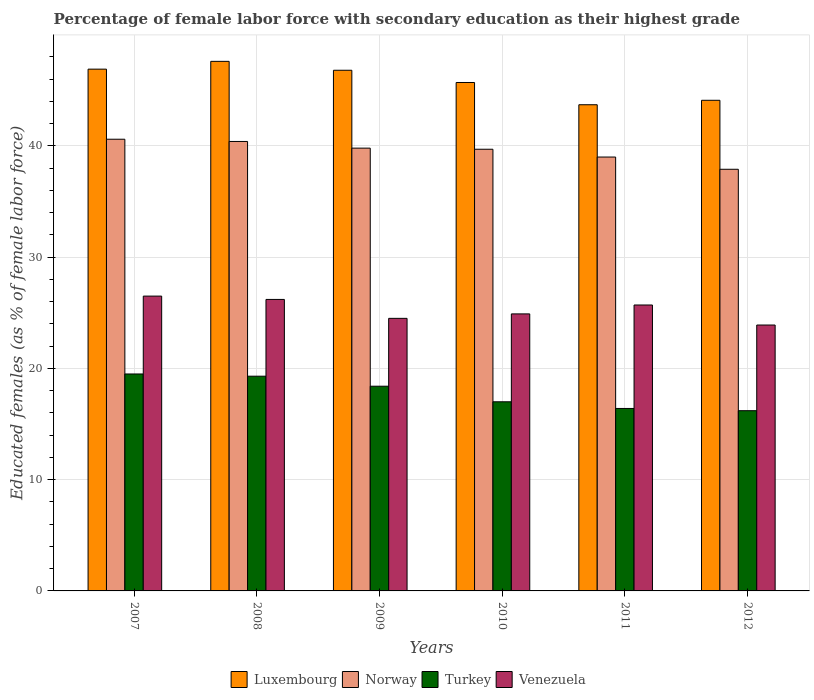How many different coloured bars are there?
Provide a short and direct response. 4. Are the number of bars on each tick of the X-axis equal?
Make the answer very short. Yes. How many bars are there on the 6th tick from the right?
Provide a short and direct response. 4. In how many cases, is the number of bars for a given year not equal to the number of legend labels?
Your answer should be compact. 0. What is the percentage of female labor force with secondary education in Norway in 2008?
Your answer should be very brief. 40.4. Across all years, what is the maximum percentage of female labor force with secondary education in Venezuela?
Your answer should be very brief. 26.5. Across all years, what is the minimum percentage of female labor force with secondary education in Turkey?
Your answer should be very brief. 16.2. In which year was the percentage of female labor force with secondary education in Norway maximum?
Give a very brief answer. 2007. What is the total percentage of female labor force with secondary education in Luxembourg in the graph?
Your answer should be compact. 274.8. What is the difference between the percentage of female labor force with secondary education in Turkey in 2010 and that in 2011?
Make the answer very short. 0.6. What is the difference between the percentage of female labor force with secondary education in Turkey in 2007 and the percentage of female labor force with secondary education in Norway in 2009?
Give a very brief answer. -20.3. What is the average percentage of female labor force with secondary education in Luxembourg per year?
Give a very brief answer. 45.8. In the year 2009, what is the difference between the percentage of female labor force with secondary education in Luxembourg and percentage of female labor force with secondary education in Norway?
Make the answer very short. 7. What is the ratio of the percentage of female labor force with secondary education in Luxembourg in 2009 to that in 2011?
Keep it short and to the point. 1.07. Is the percentage of female labor force with secondary education in Turkey in 2007 less than that in 2011?
Your response must be concise. No. What is the difference between the highest and the second highest percentage of female labor force with secondary education in Turkey?
Make the answer very short. 0.2. What is the difference between the highest and the lowest percentage of female labor force with secondary education in Venezuela?
Your answer should be very brief. 2.6. In how many years, is the percentage of female labor force with secondary education in Norway greater than the average percentage of female labor force with secondary education in Norway taken over all years?
Offer a terse response. 4. Is the sum of the percentage of female labor force with secondary education in Venezuela in 2008 and 2011 greater than the maximum percentage of female labor force with secondary education in Turkey across all years?
Your response must be concise. Yes. Is it the case that in every year, the sum of the percentage of female labor force with secondary education in Luxembourg and percentage of female labor force with secondary education in Norway is greater than the sum of percentage of female labor force with secondary education in Turkey and percentage of female labor force with secondary education in Venezuela?
Offer a terse response. Yes. What does the 1st bar from the left in 2007 represents?
Give a very brief answer. Luxembourg. Is it the case that in every year, the sum of the percentage of female labor force with secondary education in Luxembourg and percentage of female labor force with secondary education in Norway is greater than the percentage of female labor force with secondary education in Venezuela?
Provide a short and direct response. Yes. How many bars are there?
Your answer should be very brief. 24. Are all the bars in the graph horizontal?
Provide a short and direct response. No. What is the difference between two consecutive major ticks on the Y-axis?
Ensure brevity in your answer.  10. Does the graph contain any zero values?
Your answer should be very brief. No. Does the graph contain grids?
Keep it short and to the point. Yes. Where does the legend appear in the graph?
Your answer should be compact. Bottom center. What is the title of the graph?
Provide a short and direct response. Percentage of female labor force with secondary education as their highest grade. Does "Montenegro" appear as one of the legend labels in the graph?
Ensure brevity in your answer.  No. What is the label or title of the X-axis?
Provide a succinct answer. Years. What is the label or title of the Y-axis?
Your answer should be compact. Educated females (as % of female labor force). What is the Educated females (as % of female labor force) of Luxembourg in 2007?
Offer a terse response. 46.9. What is the Educated females (as % of female labor force) in Norway in 2007?
Make the answer very short. 40.6. What is the Educated females (as % of female labor force) in Turkey in 2007?
Ensure brevity in your answer.  19.5. What is the Educated females (as % of female labor force) in Luxembourg in 2008?
Keep it short and to the point. 47.6. What is the Educated females (as % of female labor force) of Norway in 2008?
Give a very brief answer. 40.4. What is the Educated females (as % of female labor force) of Turkey in 2008?
Keep it short and to the point. 19.3. What is the Educated females (as % of female labor force) of Venezuela in 2008?
Offer a very short reply. 26.2. What is the Educated females (as % of female labor force) of Luxembourg in 2009?
Make the answer very short. 46.8. What is the Educated females (as % of female labor force) of Norway in 2009?
Your response must be concise. 39.8. What is the Educated females (as % of female labor force) in Turkey in 2009?
Give a very brief answer. 18.4. What is the Educated females (as % of female labor force) in Venezuela in 2009?
Provide a short and direct response. 24.5. What is the Educated females (as % of female labor force) in Luxembourg in 2010?
Offer a very short reply. 45.7. What is the Educated females (as % of female labor force) in Norway in 2010?
Your response must be concise. 39.7. What is the Educated females (as % of female labor force) in Venezuela in 2010?
Your response must be concise. 24.9. What is the Educated females (as % of female labor force) in Luxembourg in 2011?
Your answer should be very brief. 43.7. What is the Educated females (as % of female labor force) of Turkey in 2011?
Your answer should be compact. 16.4. What is the Educated females (as % of female labor force) in Venezuela in 2011?
Provide a succinct answer. 25.7. What is the Educated females (as % of female labor force) in Luxembourg in 2012?
Provide a succinct answer. 44.1. What is the Educated females (as % of female labor force) of Norway in 2012?
Offer a very short reply. 37.9. What is the Educated females (as % of female labor force) of Turkey in 2012?
Your answer should be compact. 16.2. What is the Educated females (as % of female labor force) in Venezuela in 2012?
Give a very brief answer. 23.9. Across all years, what is the maximum Educated females (as % of female labor force) of Luxembourg?
Ensure brevity in your answer.  47.6. Across all years, what is the maximum Educated females (as % of female labor force) in Norway?
Ensure brevity in your answer.  40.6. Across all years, what is the maximum Educated females (as % of female labor force) in Turkey?
Your answer should be very brief. 19.5. Across all years, what is the maximum Educated females (as % of female labor force) in Venezuela?
Provide a short and direct response. 26.5. Across all years, what is the minimum Educated females (as % of female labor force) in Luxembourg?
Your answer should be very brief. 43.7. Across all years, what is the minimum Educated females (as % of female labor force) in Norway?
Make the answer very short. 37.9. Across all years, what is the minimum Educated females (as % of female labor force) in Turkey?
Offer a terse response. 16.2. Across all years, what is the minimum Educated females (as % of female labor force) of Venezuela?
Give a very brief answer. 23.9. What is the total Educated females (as % of female labor force) of Luxembourg in the graph?
Your answer should be compact. 274.8. What is the total Educated females (as % of female labor force) of Norway in the graph?
Give a very brief answer. 237.4. What is the total Educated females (as % of female labor force) in Turkey in the graph?
Provide a succinct answer. 106.8. What is the total Educated females (as % of female labor force) in Venezuela in the graph?
Provide a succinct answer. 151.7. What is the difference between the Educated females (as % of female labor force) in Luxembourg in 2007 and that in 2008?
Offer a very short reply. -0.7. What is the difference between the Educated females (as % of female labor force) in Norway in 2007 and that in 2008?
Offer a terse response. 0.2. What is the difference between the Educated females (as % of female labor force) in Turkey in 2007 and that in 2008?
Your answer should be compact. 0.2. What is the difference between the Educated females (as % of female labor force) of Luxembourg in 2007 and that in 2009?
Your response must be concise. 0.1. What is the difference between the Educated females (as % of female labor force) in Norway in 2007 and that in 2009?
Your answer should be compact. 0.8. What is the difference between the Educated females (as % of female labor force) of Luxembourg in 2007 and that in 2011?
Make the answer very short. 3.2. What is the difference between the Educated females (as % of female labor force) of Turkey in 2007 and that in 2011?
Provide a short and direct response. 3.1. What is the difference between the Educated females (as % of female labor force) of Venezuela in 2007 and that in 2011?
Your answer should be compact. 0.8. What is the difference between the Educated females (as % of female labor force) of Luxembourg in 2007 and that in 2012?
Give a very brief answer. 2.8. What is the difference between the Educated females (as % of female labor force) in Luxembourg in 2008 and that in 2009?
Make the answer very short. 0.8. What is the difference between the Educated females (as % of female labor force) in Turkey in 2008 and that in 2009?
Keep it short and to the point. 0.9. What is the difference between the Educated females (as % of female labor force) in Venezuela in 2008 and that in 2009?
Your answer should be very brief. 1.7. What is the difference between the Educated females (as % of female labor force) in Norway in 2008 and that in 2010?
Offer a terse response. 0.7. What is the difference between the Educated females (as % of female labor force) of Venezuela in 2008 and that in 2010?
Offer a terse response. 1.3. What is the difference between the Educated females (as % of female labor force) in Luxembourg in 2008 and that in 2011?
Offer a very short reply. 3.9. What is the difference between the Educated females (as % of female labor force) in Venezuela in 2008 and that in 2011?
Offer a terse response. 0.5. What is the difference between the Educated females (as % of female labor force) of Turkey in 2008 and that in 2012?
Offer a very short reply. 3.1. What is the difference between the Educated females (as % of female labor force) of Luxembourg in 2009 and that in 2010?
Provide a short and direct response. 1.1. What is the difference between the Educated females (as % of female labor force) of Norway in 2009 and that in 2011?
Keep it short and to the point. 0.8. What is the difference between the Educated females (as % of female labor force) in Turkey in 2009 and that in 2011?
Ensure brevity in your answer.  2. What is the difference between the Educated females (as % of female labor force) of Venezuela in 2009 and that in 2011?
Offer a terse response. -1.2. What is the difference between the Educated females (as % of female labor force) in Luxembourg in 2009 and that in 2012?
Your response must be concise. 2.7. What is the difference between the Educated females (as % of female labor force) of Norway in 2009 and that in 2012?
Keep it short and to the point. 1.9. What is the difference between the Educated females (as % of female labor force) in Venezuela in 2009 and that in 2012?
Offer a very short reply. 0.6. What is the difference between the Educated females (as % of female labor force) of Norway in 2010 and that in 2011?
Keep it short and to the point. 0.7. What is the difference between the Educated females (as % of female labor force) in Turkey in 2010 and that in 2011?
Keep it short and to the point. 0.6. What is the difference between the Educated females (as % of female labor force) of Venezuela in 2010 and that in 2011?
Offer a very short reply. -0.8. What is the difference between the Educated females (as % of female labor force) of Luxembourg in 2010 and that in 2012?
Ensure brevity in your answer.  1.6. What is the difference between the Educated females (as % of female labor force) of Venezuela in 2011 and that in 2012?
Provide a short and direct response. 1.8. What is the difference between the Educated females (as % of female labor force) of Luxembourg in 2007 and the Educated females (as % of female labor force) of Turkey in 2008?
Your response must be concise. 27.6. What is the difference between the Educated females (as % of female labor force) of Luxembourg in 2007 and the Educated females (as % of female labor force) of Venezuela in 2008?
Provide a succinct answer. 20.7. What is the difference between the Educated females (as % of female labor force) in Norway in 2007 and the Educated females (as % of female labor force) in Turkey in 2008?
Ensure brevity in your answer.  21.3. What is the difference between the Educated females (as % of female labor force) in Turkey in 2007 and the Educated females (as % of female labor force) in Venezuela in 2008?
Give a very brief answer. -6.7. What is the difference between the Educated females (as % of female labor force) of Luxembourg in 2007 and the Educated females (as % of female labor force) of Turkey in 2009?
Offer a terse response. 28.5. What is the difference between the Educated females (as % of female labor force) of Luxembourg in 2007 and the Educated females (as % of female labor force) of Venezuela in 2009?
Keep it short and to the point. 22.4. What is the difference between the Educated females (as % of female labor force) of Norway in 2007 and the Educated females (as % of female labor force) of Turkey in 2009?
Offer a very short reply. 22.2. What is the difference between the Educated females (as % of female labor force) in Luxembourg in 2007 and the Educated females (as % of female labor force) in Turkey in 2010?
Give a very brief answer. 29.9. What is the difference between the Educated females (as % of female labor force) of Norway in 2007 and the Educated females (as % of female labor force) of Turkey in 2010?
Your response must be concise. 23.6. What is the difference between the Educated females (as % of female labor force) of Luxembourg in 2007 and the Educated females (as % of female labor force) of Turkey in 2011?
Offer a terse response. 30.5. What is the difference between the Educated females (as % of female labor force) in Luxembourg in 2007 and the Educated females (as % of female labor force) in Venezuela in 2011?
Your answer should be very brief. 21.2. What is the difference between the Educated females (as % of female labor force) of Norway in 2007 and the Educated females (as % of female labor force) of Turkey in 2011?
Make the answer very short. 24.2. What is the difference between the Educated females (as % of female labor force) of Norway in 2007 and the Educated females (as % of female labor force) of Venezuela in 2011?
Offer a very short reply. 14.9. What is the difference between the Educated females (as % of female labor force) in Turkey in 2007 and the Educated females (as % of female labor force) in Venezuela in 2011?
Ensure brevity in your answer.  -6.2. What is the difference between the Educated females (as % of female labor force) in Luxembourg in 2007 and the Educated females (as % of female labor force) in Turkey in 2012?
Provide a short and direct response. 30.7. What is the difference between the Educated females (as % of female labor force) of Luxembourg in 2007 and the Educated females (as % of female labor force) of Venezuela in 2012?
Your response must be concise. 23. What is the difference between the Educated females (as % of female labor force) in Norway in 2007 and the Educated females (as % of female labor force) in Turkey in 2012?
Provide a short and direct response. 24.4. What is the difference between the Educated females (as % of female labor force) of Turkey in 2007 and the Educated females (as % of female labor force) of Venezuela in 2012?
Make the answer very short. -4.4. What is the difference between the Educated females (as % of female labor force) in Luxembourg in 2008 and the Educated females (as % of female labor force) in Norway in 2009?
Ensure brevity in your answer.  7.8. What is the difference between the Educated females (as % of female labor force) of Luxembourg in 2008 and the Educated females (as % of female labor force) of Turkey in 2009?
Provide a short and direct response. 29.2. What is the difference between the Educated females (as % of female labor force) in Luxembourg in 2008 and the Educated females (as % of female labor force) in Venezuela in 2009?
Your answer should be compact. 23.1. What is the difference between the Educated females (as % of female labor force) of Norway in 2008 and the Educated females (as % of female labor force) of Venezuela in 2009?
Provide a short and direct response. 15.9. What is the difference between the Educated females (as % of female labor force) in Luxembourg in 2008 and the Educated females (as % of female labor force) in Norway in 2010?
Provide a short and direct response. 7.9. What is the difference between the Educated females (as % of female labor force) in Luxembourg in 2008 and the Educated females (as % of female labor force) in Turkey in 2010?
Ensure brevity in your answer.  30.6. What is the difference between the Educated females (as % of female labor force) of Luxembourg in 2008 and the Educated females (as % of female labor force) of Venezuela in 2010?
Provide a succinct answer. 22.7. What is the difference between the Educated females (as % of female labor force) of Norway in 2008 and the Educated females (as % of female labor force) of Turkey in 2010?
Offer a very short reply. 23.4. What is the difference between the Educated females (as % of female labor force) of Luxembourg in 2008 and the Educated females (as % of female labor force) of Turkey in 2011?
Ensure brevity in your answer.  31.2. What is the difference between the Educated females (as % of female labor force) of Luxembourg in 2008 and the Educated females (as % of female labor force) of Venezuela in 2011?
Offer a very short reply. 21.9. What is the difference between the Educated females (as % of female labor force) in Norway in 2008 and the Educated females (as % of female labor force) in Turkey in 2011?
Your answer should be compact. 24. What is the difference between the Educated females (as % of female labor force) of Luxembourg in 2008 and the Educated females (as % of female labor force) of Norway in 2012?
Keep it short and to the point. 9.7. What is the difference between the Educated females (as % of female labor force) in Luxembourg in 2008 and the Educated females (as % of female labor force) in Turkey in 2012?
Provide a succinct answer. 31.4. What is the difference between the Educated females (as % of female labor force) in Luxembourg in 2008 and the Educated females (as % of female labor force) in Venezuela in 2012?
Provide a succinct answer. 23.7. What is the difference between the Educated females (as % of female labor force) of Norway in 2008 and the Educated females (as % of female labor force) of Turkey in 2012?
Your answer should be compact. 24.2. What is the difference between the Educated females (as % of female labor force) of Turkey in 2008 and the Educated females (as % of female labor force) of Venezuela in 2012?
Your answer should be compact. -4.6. What is the difference between the Educated females (as % of female labor force) of Luxembourg in 2009 and the Educated females (as % of female labor force) of Turkey in 2010?
Offer a very short reply. 29.8. What is the difference between the Educated females (as % of female labor force) of Luxembourg in 2009 and the Educated females (as % of female labor force) of Venezuela in 2010?
Your response must be concise. 21.9. What is the difference between the Educated females (as % of female labor force) in Norway in 2009 and the Educated females (as % of female labor force) in Turkey in 2010?
Give a very brief answer. 22.8. What is the difference between the Educated females (as % of female labor force) in Luxembourg in 2009 and the Educated females (as % of female labor force) in Norway in 2011?
Give a very brief answer. 7.8. What is the difference between the Educated females (as % of female labor force) in Luxembourg in 2009 and the Educated females (as % of female labor force) in Turkey in 2011?
Make the answer very short. 30.4. What is the difference between the Educated females (as % of female labor force) of Luxembourg in 2009 and the Educated females (as % of female labor force) of Venezuela in 2011?
Your answer should be compact. 21.1. What is the difference between the Educated females (as % of female labor force) of Norway in 2009 and the Educated females (as % of female labor force) of Turkey in 2011?
Make the answer very short. 23.4. What is the difference between the Educated females (as % of female labor force) in Norway in 2009 and the Educated females (as % of female labor force) in Venezuela in 2011?
Your answer should be compact. 14.1. What is the difference between the Educated females (as % of female labor force) of Turkey in 2009 and the Educated females (as % of female labor force) of Venezuela in 2011?
Make the answer very short. -7.3. What is the difference between the Educated females (as % of female labor force) of Luxembourg in 2009 and the Educated females (as % of female labor force) of Turkey in 2012?
Make the answer very short. 30.6. What is the difference between the Educated females (as % of female labor force) in Luxembourg in 2009 and the Educated females (as % of female labor force) in Venezuela in 2012?
Your answer should be very brief. 22.9. What is the difference between the Educated females (as % of female labor force) in Norway in 2009 and the Educated females (as % of female labor force) in Turkey in 2012?
Make the answer very short. 23.6. What is the difference between the Educated females (as % of female labor force) in Turkey in 2009 and the Educated females (as % of female labor force) in Venezuela in 2012?
Your answer should be very brief. -5.5. What is the difference between the Educated females (as % of female labor force) in Luxembourg in 2010 and the Educated females (as % of female labor force) in Norway in 2011?
Ensure brevity in your answer.  6.7. What is the difference between the Educated females (as % of female labor force) in Luxembourg in 2010 and the Educated females (as % of female labor force) in Turkey in 2011?
Your response must be concise. 29.3. What is the difference between the Educated females (as % of female labor force) in Luxembourg in 2010 and the Educated females (as % of female labor force) in Venezuela in 2011?
Ensure brevity in your answer.  20. What is the difference between the Educated females (as % of female labor force) of Norway in 2010 and the Educated females (as % of female labor force) of Turkey in 2011?
Your answer should be compact. 23.3. What is the difference between the Educated females (as % of female labor force) in Norway in 2010 and the Educated females (as % of female labor force) in Venezuela in 2011?
Your answer should be compact. 14. What is the difference between the Educated females (as % of female labor force) in Luxembourg in 2010 and the Educated females (as % of female labor force) in Norway in 2012?
Offer a terse response. 7.8. What is the difference between the Educated females (as % of female labor force) in Luxembourg in 2010 and the Educated females (as % of female labor force) in Turkey in 2012?
Keep it short and to the point. 29.5. What is the difference between the Educated females (as % of female labor force) of Luxembourg in 2010 and the Educated females (as % of female labor force) of Venezuela in 2012?
Make the answer very short. 21.8. What is the difference between the Educated females (as % of female labor force) of Luxembourg in 2011 and the Educated females (as % of female labor force) of Norway in 2012?
Your answer should be compact. 5.8. What is the difference between the Educated females (as % of female labor force) in Luxembourg in 2011 and the Educated females (as % of female labor force) in Turkey in 2012?
Keep it short and to the point. 27.5. What is the difference between the Educated females (as % of female labor force) in Luxembourg in 2011 and the Educated females (as % of female labor force) in Venezuela in 2012?
Offer a very short reply. 19.8. What is the difference between the Educated females (as % of female labor force) in Norway in 2011 and the Educated females (as % of female labor force) in Turkey in 2012?
Give a very brief answer. 22.8. What is the difference between the Educated females (as % of female labor force) in Norway in 2011 and the Educated females (as % of female labor force) in Venezuela in 2012?
Provide a succinct answer. 15.1. What is the average Educated females (as % of female labor force) in Luxembourg per year?
Provide a succinct answer. 45.8. What is the average Educated females (as % of female labor force) of Norway per year?
Make the answer very short. 39.57. What is the average Educated females (as % of female labor force) in Turkey per year?
Keep it short and to the point. 17.8. What is the average Educated females (as % of female labor force) in Venezuela per year?
Your answer should be compact. 25.28. In the year 2007, what is the difference between the Educated females (as % of female labor force) in Luxembourg and Educated females (as % of female labor force) in Turkey?
Give a very brief answer. 27.4. In the year 2007, what is the difference between the Educated females (as % of female labor force) of Luxembourg and Educated females (as % of female labor force) of Venezuela?
Make the answer very short. 20.4. In the year 2007, what is the difference between the Educated females (as % of female labor force) in Norway and Educated females (as % of female labor force) in Turkey?
Provide a short and direct response. 21.1. In the year 2007, what is the difference between the Educated females (as % of female labor force) of Norway and Educated females (as % of female labor force) of Venezuela?
Offer a very short reply. 14.1. In the year 2007, what is the difference between the Educated females (as % of female labor force) of Turkey and Educated females (as % of female labor force) of Venezuela?
Give a very brief answer. -7. In the year 2008, what is the difference between the Educated females (as % of female labor force) of Luxembourg and Educated females (as % of female labor force) of Norway?
Offer a very short reply. 7.2. In the year 2008, what is the difference between the Educated females (as % of female labor force) of Luxembourg and Educated females (as % of female labor force) of Turkey?
Offer a very short reply. 28.3. In the year 2008, what is the difference between the Educated females (as % of female labor force) of Luxembourg and Educated females (as % of female labor force) of Venezuela?
Your answer should be very brief. 21.4. In the year 2008, what is the difference between the Educated females (as % of female labor force) of Norway and Educated females (as % of female labor force) of Turkey?
Make the answer very short. 21.1. In the year 2009, what is the difference between the Educated females (as % of female labor force) in Luxembourg and Educated females (as % of female labor force) in Turkey?
Provide a short and direct response. 28.4. In the year 2009, what is the difference between the Educated females (as % of female labor force) in Luxembourg and Educated females (as % of female labor force) in Venezuela?
Offer a terse response. 22.3. In the year 2009, what is the difference between the Educated females (as % of female labor force) in Norway and Educated females (as % of female labor force) in Turkey?
Offer a very short reply. 21.4. In the year 2010, what is the difference between the Educated females (as % of female labor force) in Luxembourg and Educated females (as % of female labor force) in Norway?
Give a very brief answer. 6. In the year 2010, what is the difference between the Educated females (as % of female labor force) in Luxembourg and Educated females (as % of female labor force) in Turkey?
Ensure brevity in your answer.  28.7. In the year 2010, what is the difference between the Educated females (as % of female labor force) in Luxembourg and Educated females (as % of female labor force) in Venezuela?
Your response must be concise. 20.8. In the year 2010, what is the difference between the Educated females (as % of female labor force) in Norway and Educated females (as % of female labor force) in Turkey?
Ensure brevity in your answer.  22.7. In the year 2010, what is the difference between the Educated females (as % of female labor force) of Norway and Educated females (as % of female labor force) of Venezuela?
Your answer should be very brief. 14.8. In the year 2010, what is the difference between the Educated females (as % of female labor force) in Turkey and Educated females (as % of female labor force) in Venezuela?
Keep it short and to the point. -7.9. In the year 2011, what is the difference between the Educated females (as % of female labor force) of Luxembourg and Educated females (as % of female labor force) of Turkey?
Give a very brief answer. 27.3. In the year 2011, what is the difference between the Educated females (as % of female labor force) of Luxembourg and Educated females (as % of female labor force) of Venezuela?
Your answer should be compact. 18. In the year 2011, what is the difference between the Educated females (as % of female labor force) of Norway and Educated females (as % of female labor force) of Turkey?
Give a very brief answer. 22.6. In the year 2011, what is the difference between the Educated females (as % of female labor force) of Norway and Educated females (as % of female labor force) of Venezuela?
Your answer should be compact. 13.3. In the year 2011, what is the difference between the Educated females (as % of female labor force) in Turkey and Educated females (as % of female labor force) in Venezuela?
Ensure brevity in your answer.  -9.3. In the year 2012, what is the difference between the Educated females (as % of female labor force) in Luxembourg and Educated females (as % of female labor force) in Norway?
Give a very brief answer. 6.2. In the year 2012, what is the difference between the Educated females (as % of female labor force) in Luxembourg and Educated females (as % of female labor force) in Turkey?
Make the answer very short. 27.9. In the year 2012, what is the difference between the Educated females (as % of female labor force) of Luxembourg and Educated females (as % of female labor force) of Venezuela?
Make the answer very short. 20.2. In the year 2012, what is the difference between the Educated females (as % of female labor force) in Norway and Educated females (as % of female labor force) in Turkey?
Keep it short and to the point. 21.7. What is the ratio of the Educated females (as % of female labor force) in Turkey in 2007 to that in 2008?
Your answer should be compact. 1.01. What is the ratio of the Educated females (as % of female labor force) in Venezuela in 2007 to that in 2008?
Your response must be concise. 1.01. What is the ratio of the Educated females (as % of female labor force) of Luxembourg in 2007 to that in 2009?
Make the answer very short. 1. What is the ratio of the Educated females (as % of female labor force) in Norway in 2007 to that in 2009?
Ensure brevity in your answer.  1.02. What is the ratio of the Educated females (as % of female labor force) in Turkey in 2007 to that in 2009?
Offer a terse response. 1.06. What is the ratio of the Educated females (as % of female labor force) of Venezuela in 2007 to that in 2009?
Your answer should be compact. 1.08. What is the ratio of the Educated females (as % of female labor force) in Luxembourg in 2007 to that in 2010?
Offer a very short reply. 1.03. What is the ratio of the Educated females (as % of female labor force) in Norway in 2007 to that in 2010?
Your answer should be very brief. 1.02. What is the ratio of the Educated females (as % of female labor force) in Turkey in 2007 to that in 2010?
Make the answer very short. 1.15. What is the ratio of the Educated females (as % of female labor force) of Venezuela in 2007 to that in 2010?
Your answer should be compact. 1.06. What is the ratio of the Educated females (as % of female labor force) of Luxembourg in 2007 to that in 2011?
Keep it short and to the point. 1.07. What is the ratio of the Educated females (as % of female labor force) in Norway in 2007 to that in 2011?
Offer a very short reply. 1.04. What is the ratio of the Educated females (as % of female labor force) of Turkey in 2007 to that in 2011?
Offer a very short reply. 1.19. What is the ratio of the Educated females (as % of female labor force) of Venezuela in 2007 to that in 2011?
Make the answer very short. 1.03. What is the ratio of the Educated females (as % of female labor force) of Luxembourg in 2007 to that in 2012?
Provide a succinct answer. 1.06. What is the ratio of the Educated females (as % of female labor force) of Norway in 2007 to that in 2012?
Offer a terse response. 1.07. What is the ratio of the Educated females (as % of female labor force) in Turkey in 2007 to that in 2012?
Provide a succinct answer. 1.2. What is the ratio of the Educated females (as % of female labor force) in Venezuela in 2007 to that in 2012?
Ensure brevity in your answer.  1.11. What is the ratio of the Educated females (as % of female labor force) in Luxembourg in 2008 to that in 2009?
Offer a terse response. 1.02. What is the ratio of the Educated females (as % of female labor force) of Norway in 2008 to that in 2009?
Make the answer very short. 1.02. What is the ratio of the Educated females (as % of female labor force) in Turkey in 2008 to that in 2009?
Give a very brief answer. 1.05. What is the ratio of the Educated females (as % of female labor force) in Venezuela in 2008 to that in 2009?
Offer a terse response. 1.07. What is the ratio of the Educated females (as % of female labor force) of Luxembourg in 2008 to that in 2010?
Offer a terse response. 1.04. What is the ratio of the Educated females (as % of female labor force) of Norway in 2008 to that in 2010?
Provide a short and direct response. 1.02. What is the ratio of the Educated females (as % of female labor force) in Turkey in 2008 to that in 2010?
Give a very brief answer. 1.14. What is the ratio of the Educated females (as % of female labor force) in Venezuela in 2008 to that in 2010?
Keep it short and to the point. 1.05. What is the ratio of the Educated females (as % of female labor force) in Luxembourg in 2008 to that in 2011?
Keep it short and to the point. 1.09. What is the ratio of the Educated females (as % of female labor force) of Norway in 2008 to that in 2011?
Offer a very short reply. 1.04. What is the ratio of the Educated females (as % of female labor force) of Turkey in 2008 to that in 2011?
Make the answer very short. 1.18. What is the ratio of the Educated females (as % of female labor force) of Venezuela in 2008 to that in 2011?
Offer a terse response. 1.02. What is the ratio of the Educated females (as % of female labor force) in Luxembourg in 2008 to that in 2012?
Provide a short and direct response. 1.08. What is the ratio of the Educated females (as % of female labor force) of Norway in 2008 to that in 2012?
Offer a very short reply. 1.07. What is the ratio of the Educated females (as % of female labor force) of Turkey in 2008 to that in 2012?
Give a very brief answer. 1.19. What is the ratio of the Educated females (as % of female labor force) in Venezuela in 2008 to that in 2012?
Give a very brief answer. 1.1. What is the ratio of the Educated females (as % of female labor force) of Luxembourg in 2009 to that in 2010?
Your answer should be very brief. 1.02. What is the ratio of the Educated females (as % of female labor force) of Turkey in 2009 to that in 2010?
Your answer should be very brief. 1.08. What is the ratio of the Educated females (as % of female labor force) in Venezuela in 2009 to that in 2010?
Your response must be concise. 0.98. What is the ratio of the Educated females (as % of female labor force) of Luxembourg in 2009 to that in 2011?
Provide a succinct answer. 1.07. What is the ratio of the Educated females (as % of female labor force) of Norway in 2009 to that in 2011?
Ensure brevity in your answer.  1.02. What is the ratio of the Educated females (as % of female labor force) in Turkey in 2009 to that in 2011?
Offer a terse response. 1.12. What is the ratio of the Educated females (as % of female labor force) in Venezuela in 2009 to that in 2011?
Keep it short and to the point. 0.95. What is the ratio of the Educated females (as % of female labor force) in Luxembourg in 2009 to that in 2012?
Provide a succinct answer. 1.06. What is the ratio of the Educated females (as % of female labor force) of Norway in 2009 to that in 2012?
Keep it short and to the point. 1.05. What is the ratio of the Educated females (as % of female labor force) in Turkey in 2009 to that in 2012?
Make the answer very short. 1.14. What is the ratio of the Educated females (as % of female labor force) in Venezuela in 2009 to that in 2012?
Offer a terse response. 1.03. What is the ratio of the Educated females (as % of female labor force) of Luxembourg in 2010 to that in 2011?
Your answer should be very brief. 1.05. What is the ratio of the Educated females (as % of female labor force) in Norway in 2010 to that in 2011?
Provide a short and direct response. 1.02. What is the ratio of the Educated females (as % of female labor force) of Turkey in 2010 to that in 2011?
Provide a succinct answer. 1.04. What is the ratio of the Educated females (as % of female labor force) in Venezuela in 2010 to that in 2011?
Make the answer very short. 0.97. What is the ratio of the Educated females (as % of female labor force) in Luxembourg in 2010 to that in 2012?
Keep it short and to the point. 1.04. What is the ratio of the Educated females (as % of female labor force) in Norway in 2010 to that in 2012?
Your response must be concise. 1.05. What is the ratio of the Educated females (as % of female labor force) of Turkey in 2010 to that in 2012?
Offer a very short reply. 1.05. What is the ratio of the Educated females (as % of female labor force) in Venezuela in 2010 to that in 2012?
Make the answer very short. 1.04. What is the ratio of the Educated females (as % of female labor force) of Luxembourg in 2011 to that in 2012?
Offer a very short reply. 0.99. What is the ratio of the Educated females (as % of female labor force) of Norway in 2011 to that in 2012?
Give a very brief answer. 1.03. What is the ratio of the Educated females (as % of female labor force) of Turkey in 2011 to that in 2012?
Give a very brief answer. 1.01. What is the ratio of the Educated females (as % of female labor force) in Venezuela in 2011 to that in 2012?
Give a very brief answer. 1.08. What is the difference between the highest and the second highest Educated females (as % of female labor force) in Norway?
Ensure brevity in your answer.  0.2. What is the difference between the highest and the lowest Educated females (as % of female labor force) of Venezuela?
Keep it short and to the point. 2.6. 